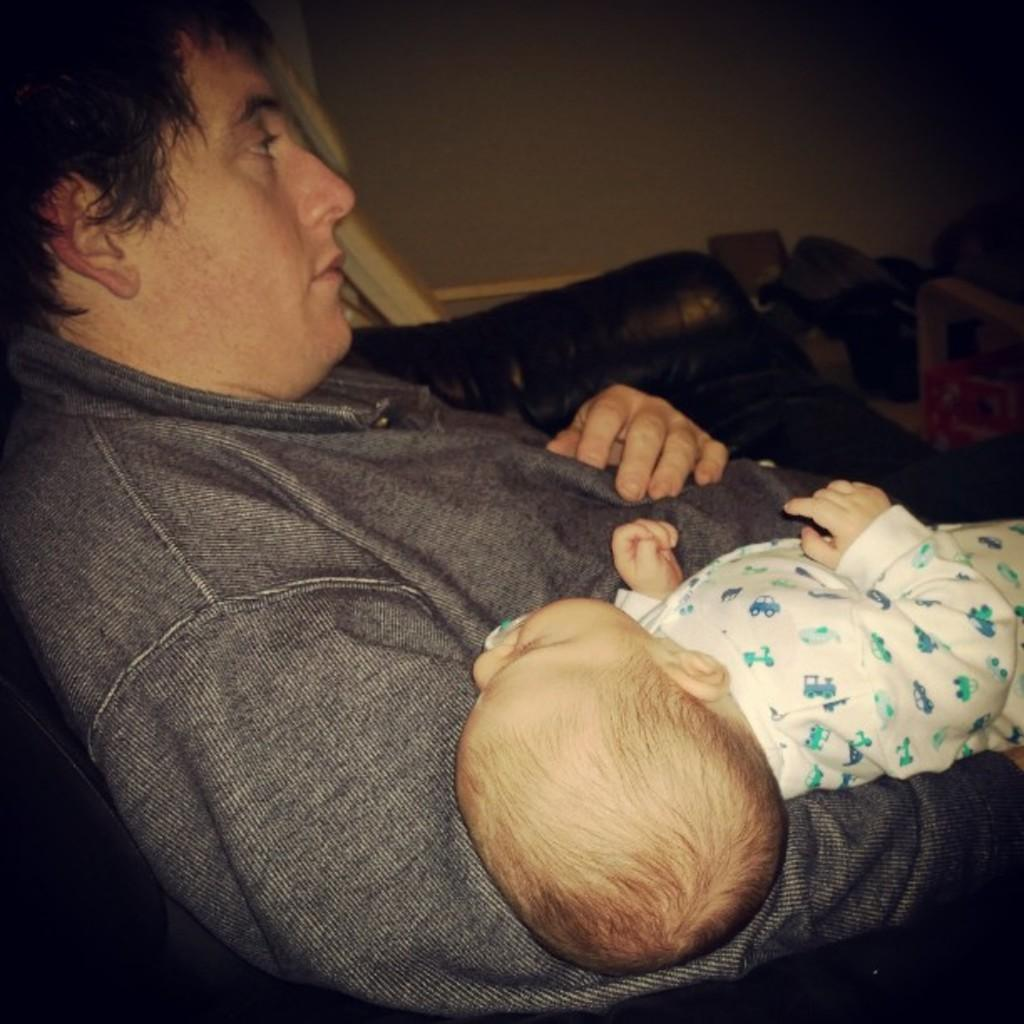Who is present in the image? There is a man in the image. What is the man doing in the image? The man is laying on a sofa. Is there anyone else in the man's arms in the image? Yes, the man is holding a baby in his arms. What else can be seen in the image besides the man and the baby? There are other things beside the sofa in the image. What type of curtain is being smashed by the baby in the image? There is no curtain present in the image, nor is the baby smashing anything. 